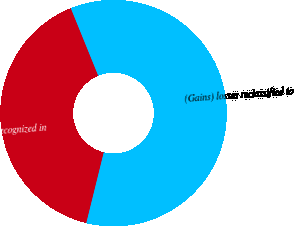Convert chart. <chart><loc_0><loc_0><loc_500><loc_500><pie_chart><fcel>Unrealized gains recognized in<fcel>(Gains) losses reclassified to<nl><fcel>40.0%<fcel>60.0%<nl></chart> 